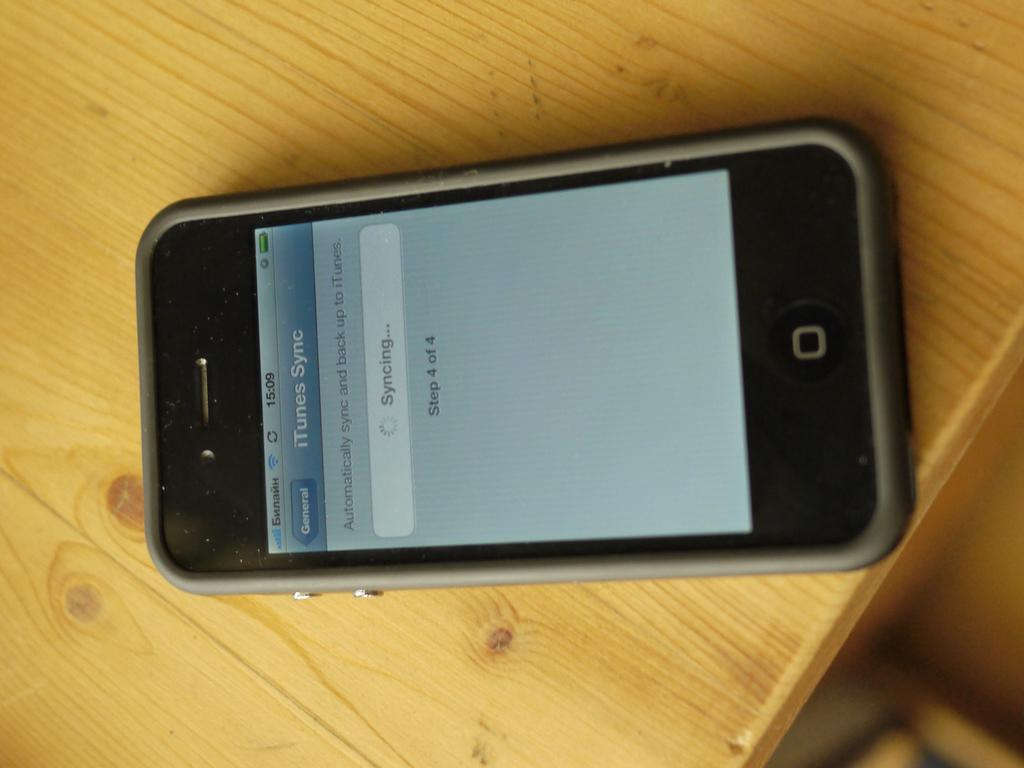What is the main object in the image? There is a table in the image. What is placed on the table? There is a cell phone on the table. Can you describe any other features of the image? There is a blurred area in the image. How many flies can be seen in the image? There are no flies visible in the image. What type of tail is attached to the cell phone in the image? There is no tail attached to the cell phone in the image. 